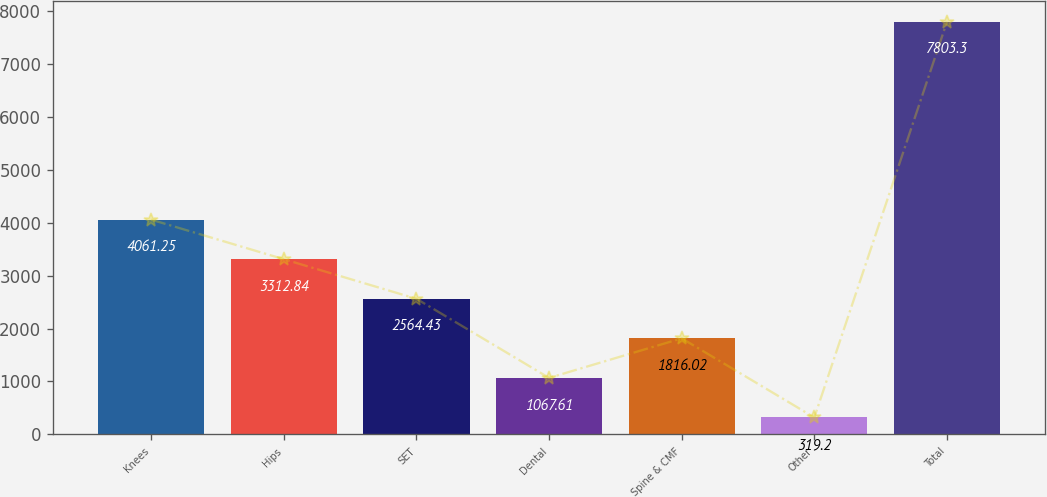<chart> <loc_0><loc_0><loc_500><loc_500><bar_chart><fcel>Knees<fcel>Hips<fcel>SET<fcel>Dental<fcel>Spine & CMF<fcel>Other<fcel>Total<nl><fcel>4061.25<fcel>3312.84<fcel>2564.43<fcel>1067.61<fcel>1816.02<fcel>319.2<fcel>7803.3<nl></chart> 